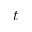<formula> <loc_0><loc_0><loc_500><loc_500>t</formula> 